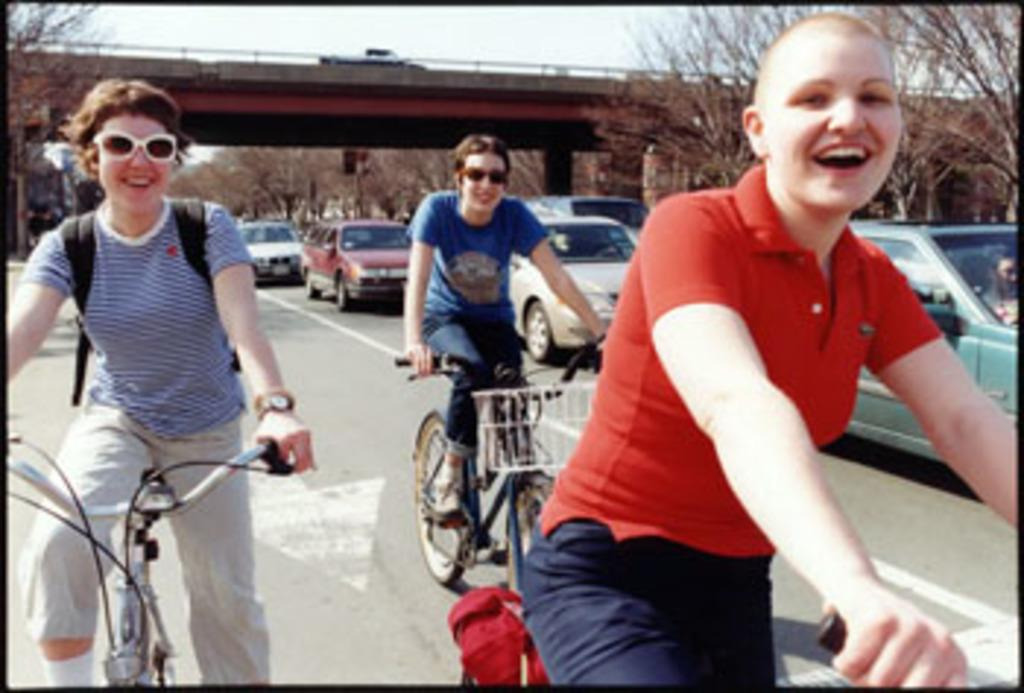What are the three people in the image doing? The three people are riding bicycles. What else can be seen on the road in the image? Cars are moving on the road. What type of infrastructure is present in the image? There is a flyover in the image. What can be seen in the background of the image? Trees are visible in the background. What type of sack is being carried by the partner in the image? There is no partner or sack present in the image. 